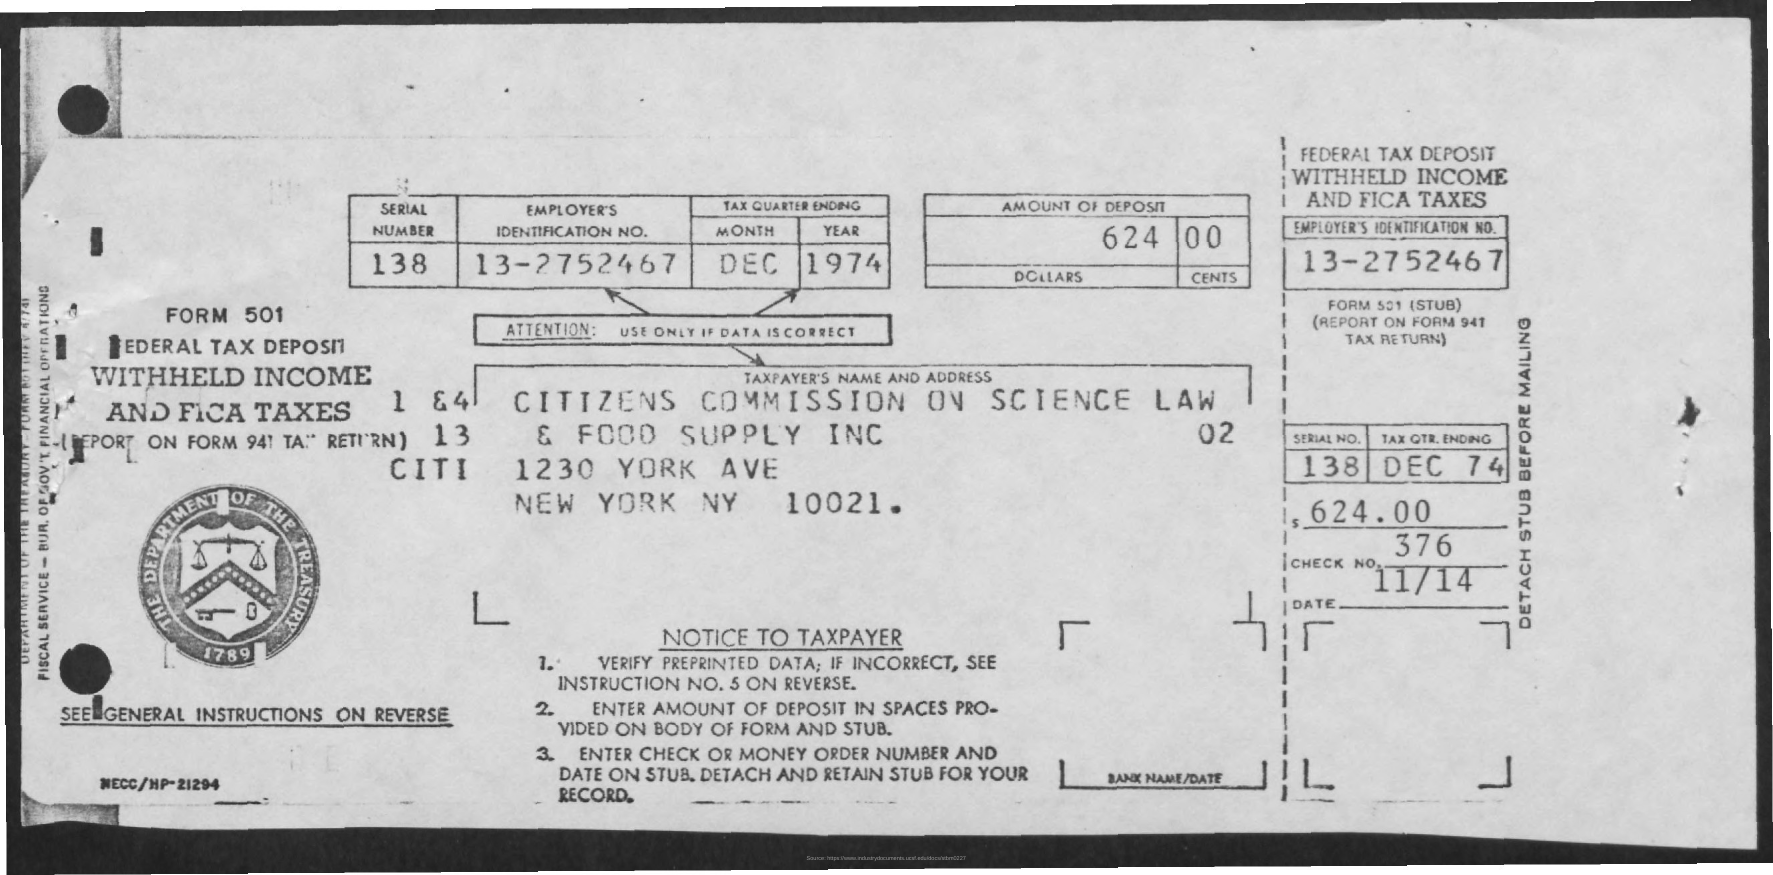What historical context might be relevant to this document from 1974? In 1974, the U.S. was facing various economic challenges, including inflation and a stock market crash the prior year. Tax documents like this one reflect corporate financial responsibilities during that period, which also saw changes in taxation and regulation under the administration of President Gerald Ford. 